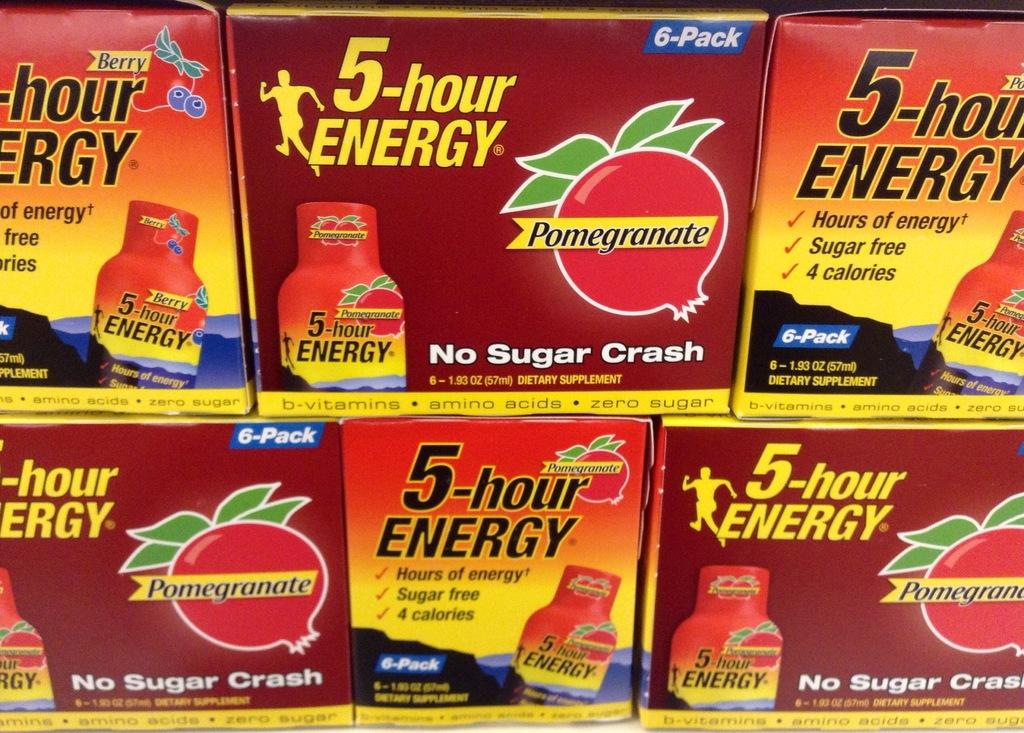<image>
Create a compact narrative representing the image presented. Several boxes of 5-hour Energy in different varieties. 